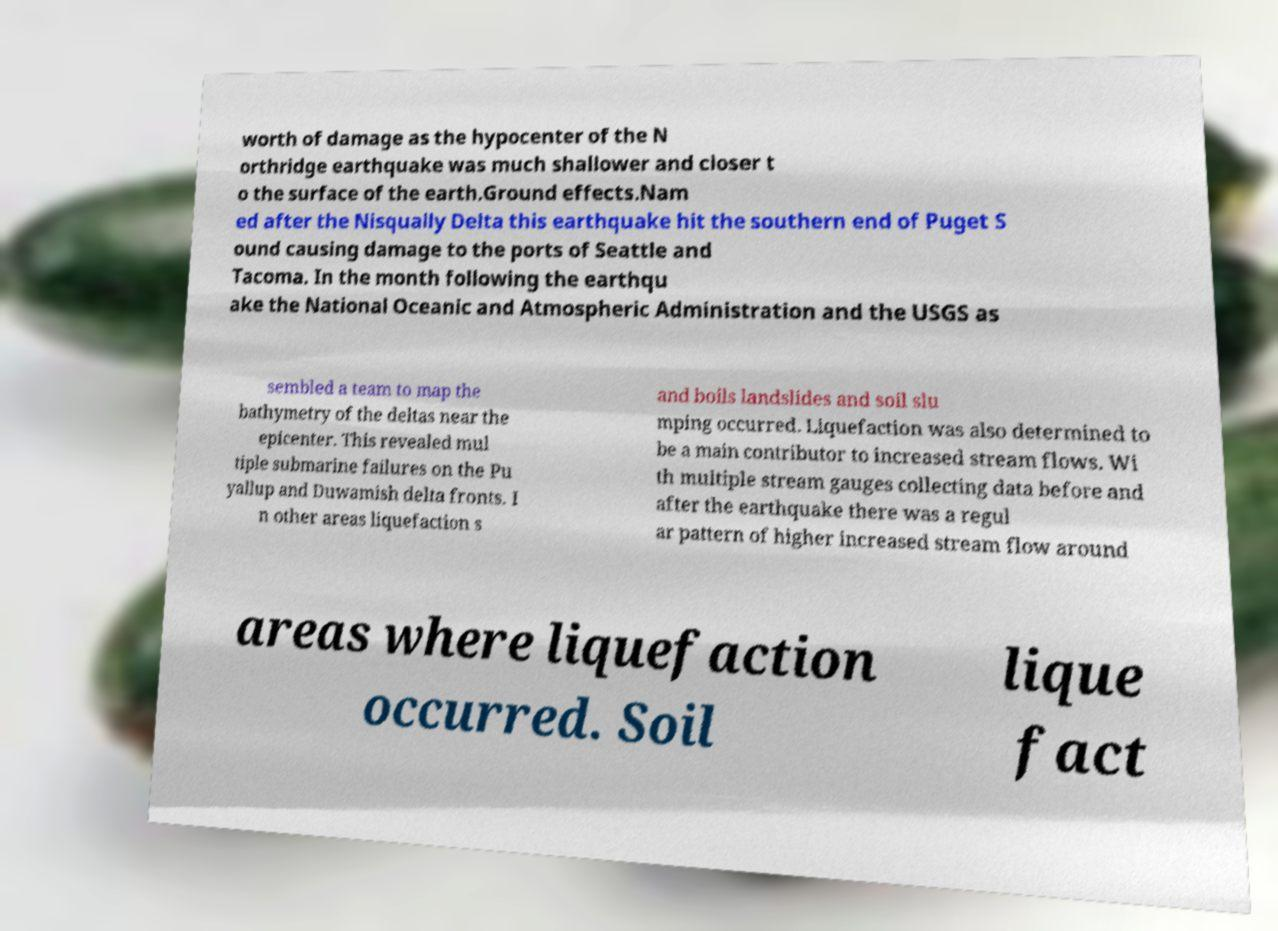I need the written content from this picture converted into text. Can you do that? worth of damage as the hypocenter of the N orthridge earthquake was much shallower and closer t o the surface of the earth.Ground effects.Nam ed after the Nisqually Delta this earthquake hit the southern end of Puget S ound causing damage to the ports of Seattle and Tacoma. In the month following the earthqu ake the National Oceanic and Atmospheric Administration and the USGS as sembled a team to map the bathymetry of the deltas near the epicenter. This revealed mul tiple submarine failures on the Pu yallup and Duwamish delta fronts. I n other areas liquefaction s and boils landslides and soil slu mping occurred. Liquefaction was also determined to be a main contributor to increased stream flows. Wi th multiple stream gauges collecting data before and after the earthquake there was a regul ar pattern of higher increased stream flow around areas where liquefaction occurred. Soil lique fact 